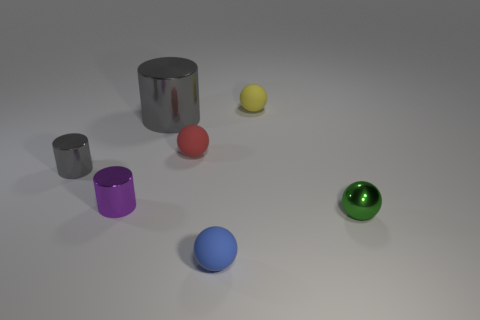Is the number of big brown matte spheres less than the number of tiny purple cylinders?
Ensure brevity in your answer.  Yes. What number of things are in front of the yellow object?
Keep it short and to the point. 6. What is the material of the tiny gray thing?
Offer a terse response. Metal. Does the large cylinder have the same color as the tiny metal ball?
Your response must be concise. No. Are there fewer tiny red rubber objects to the left of the large gray thing than small red matte objects?
Provide a short and direct response. Yes. There is a sphere that is behind the tiny red thing; what color is it?
Give a very brief answer. Yellow. What shape is the tiny green object?
Give a very brief answer. Sphere. There is a tiny shiny thing right of the matte ball that is to the right of the blue matte ball; is there a tiny green object behind it?
Keep it short and to the point. No. There is a small object to the right of the matte sphere that is on the right side of the thing that is in front of the green shiny object; what color is it?
Ensure brevity in your answer.  Green. What material is the red thing that is the same shape as the blue object?
Provide a short and direct response. Rubber. 